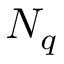Convert formula to latex. <formula><loc_0><loc_0><loc_500><loc_500>N _ { q }</formula> 